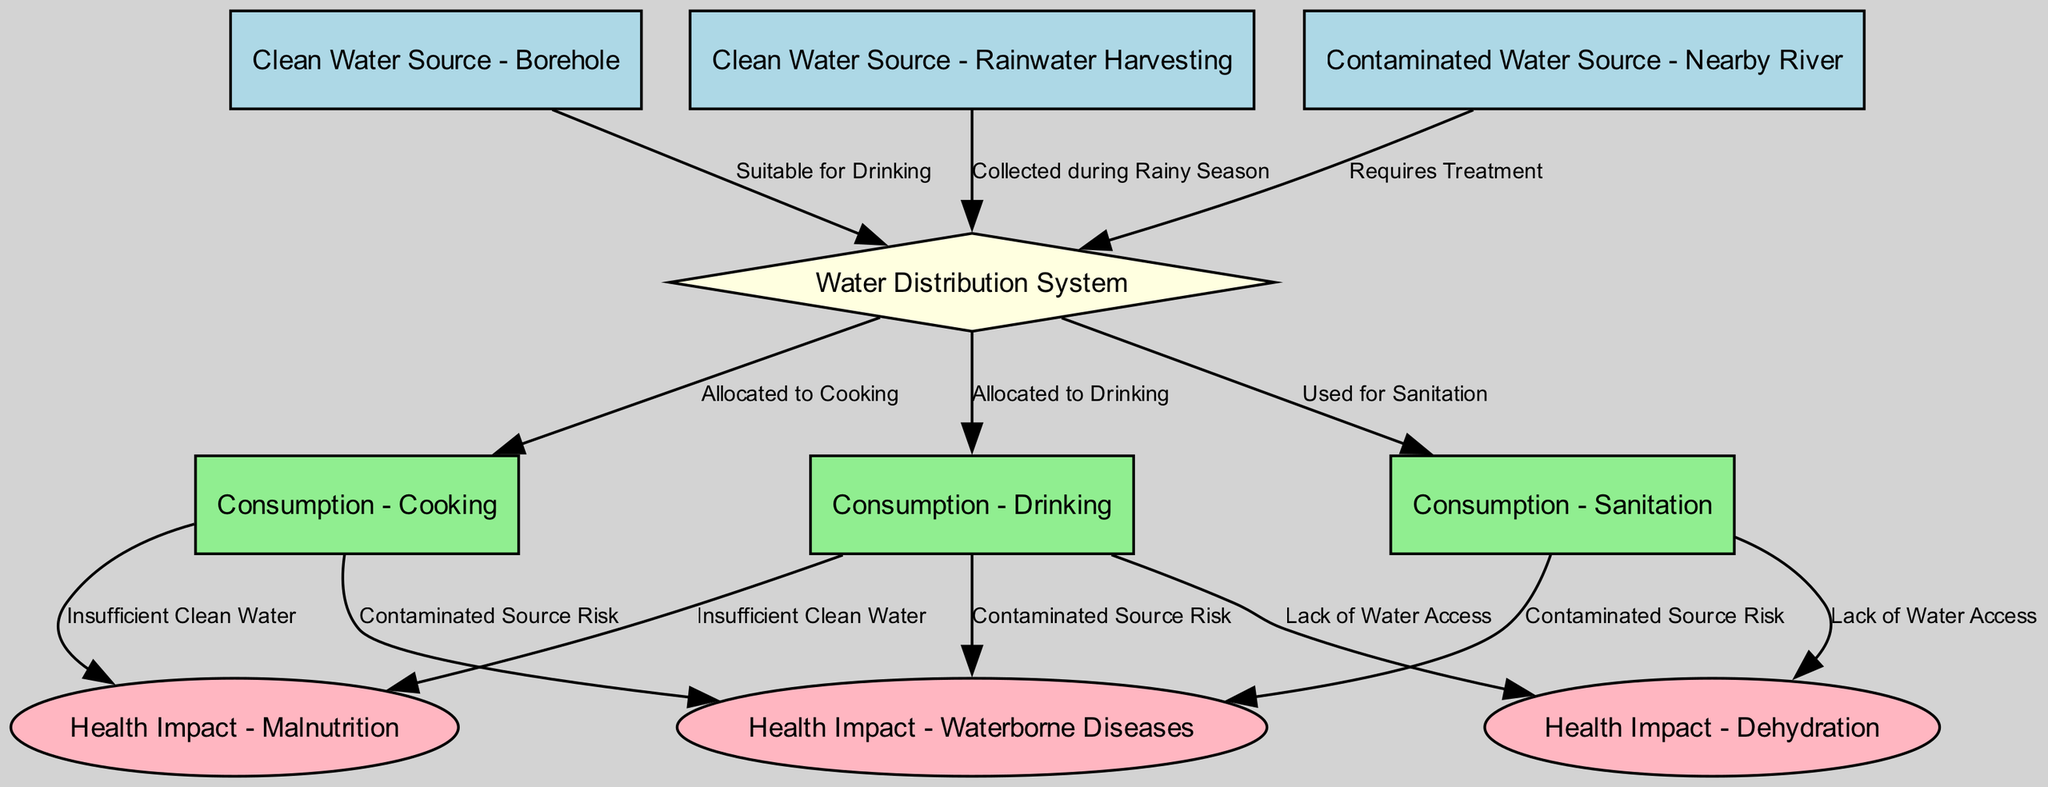What are the clean water sources listed in the diagram? The diagram outlines two clean water sources: a borehole and rainwater harvesting. These are directly mentioned under the "Clean Water Source" category in the nodes.
Answer: Borehole, Rainwater Harvesting How many consumption types are associated with water in the diagram? There are three types of consumption identified in the diagram: drinking, cooking, and sanitation. Each of these is represented as usage nodes.
Answer: 3 What role does the "Water Distribution System" play in the diagram? The "Water Distribution System" acts as a central node that receives inputs from various water sources and allocates water to different consumption usages. It highlights the distribution pathway of water in the refugee camps.
Answer: Central node for allocation Which contaminated water source is mentioned in the diagram? The diagram highlights a nearby river as a contaminated water source. It is labeled as requiring treatment before use.
Answer: Nearby River How does insufficient clean water lead to health impacts? Insufficient clean water for drinking and cooking increases the risk of malnutrition and can lead to dehydration, as shown by the edges connecting usage nodes to impact nodes. This indicates that low access to clean water directly correlates with health challenges.
Answer: Increases health risks What is the health impact associated with using contaminated water for drinking? The use of contaminated water for drinking is associated with the health impact of waterborne diseases, as indicated by the edges connecting drinking consumption to health impact nodes.
Answer: Waterborne Diseases What happens to water collected during the rainy season? Water collected during the rainy season is directed to the 'Water Distribution System' as a clean water source, emphasizing its role as a viable source of clean water at certain times of the year.
Answer: Allocated to distribution Which health impacts are indicated by both insufficient clean water and lack of water access? Both insufficient clean water and lack of water access can lead to malnutrition and dehydration, showing that limited water availability has multiple adverse health effects.
Answer: Malnutrition, Dehydration 